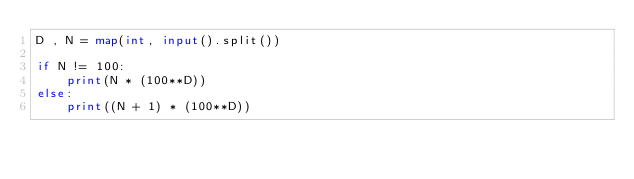Convert code to text. <code><loc_0><loc_0><loc_500><loc_500><_Python_>D , N = map(int, input().split())

if N != 100:
    print(N * (100**D))
else:
    print((N + 1) * (100**D))</code> 